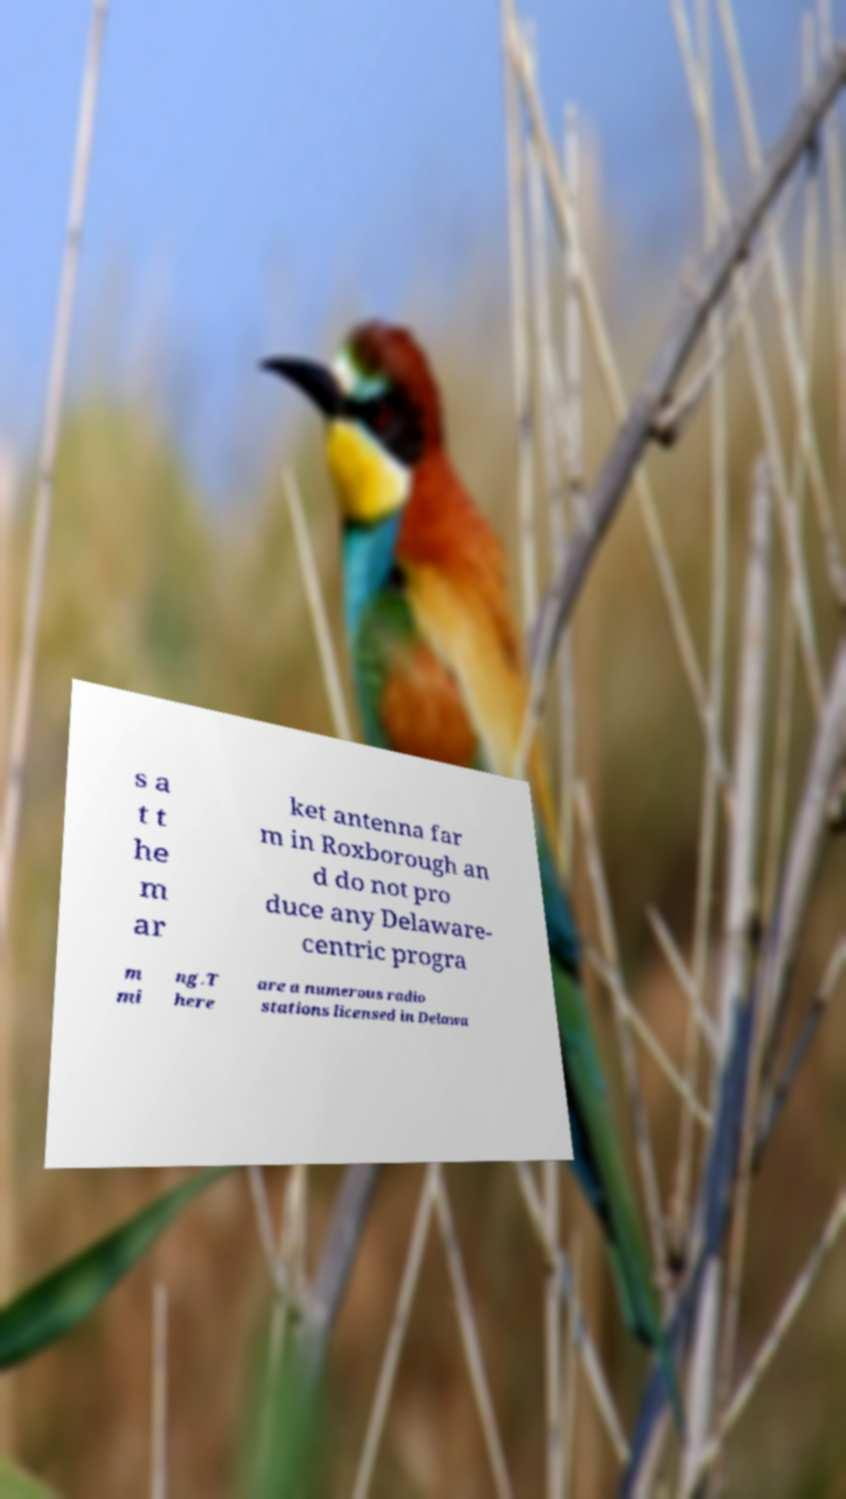I need the written content from this picture converted into text. Can you do that? s a t t he m ar ket antenna far m in Roxborough an d do not pro duce any Delaware- centric progra m mi ng.T here are a numerous radio stations licensed in Delawa 